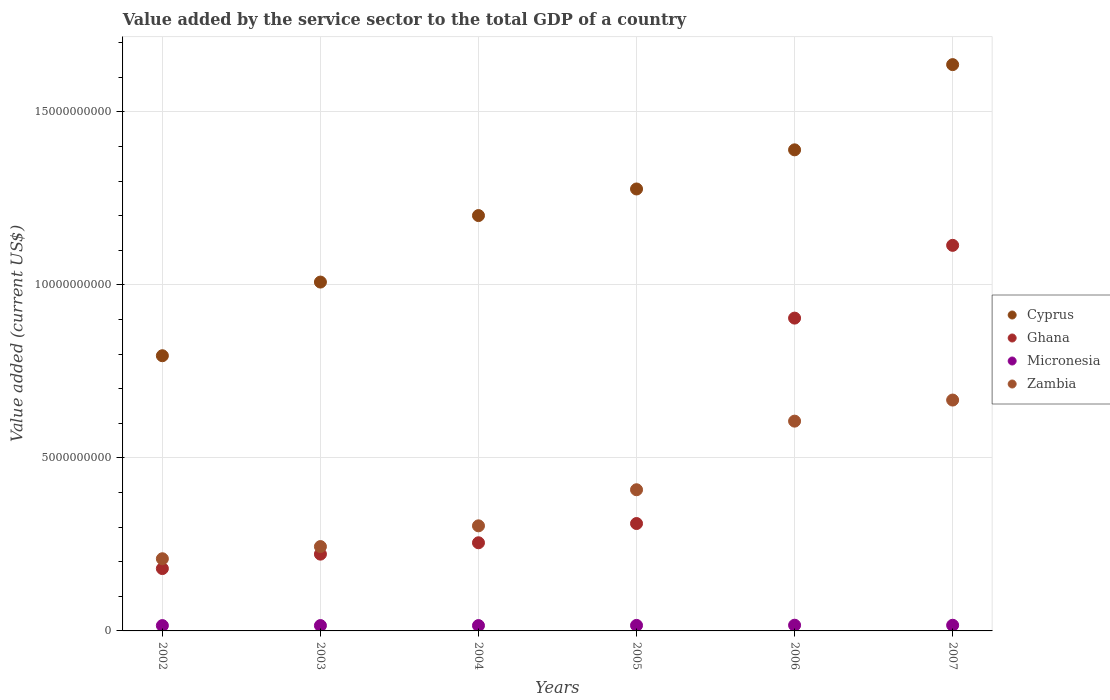Is the number of dotlines equal to the number of legend labels?
Your answer should be very brief. Yes. What is the value added by the service sector to the total GDP in Ghana in 2006?
Your response must be concise. 9.04e+09. Across all years, what is the maximum value added by the service sector to the total GDP in Ghana?
Provide a succinct answer. 1.11e+1. Across all years, what is the minimum value added by the service sector to the total GDP in Cyprus?
Keep it short and to the point. 7.95e+09. What is the total value added by the service sector to the total GDP in Ghana in the graph?
Offer a terse response. 2.98e+1. What is the difference between the value added by the service sector to the total GDP in Cyprus in 2005 and that in 2007?
Offer a terse response. -3.59e+09. What is the difference between the value added by the service sector to the total GDP in Ghana in 2004 and the value added by the service sector to the total GDP in Zambia in 2002?
Your response must be concise. 4.62e+08. What is the average value added by the service sector to the total GDP in Cyprus per year?
Ensure brevity in your answer.  1.22e+1. In the year 2005, what is the difference between the value added by the service sector to the total GDP in Zambia and value added by the service sector to the total GDP in Micronesia?
Provide a short and direct response. 3.92e+09. What is the ratio of the value added by the service sector to the total GDP in Ghana in 2002 to that in 2003?
Provide a short and direct response. 0.81. Is the value added by the service sector to the total GDP in Cyprus in 2002 less than that in 2003?
Ensure brevity in your answer.  Yes. Is the difference between the value added by the service sector to the total GDP in Zambia in 2004 and 2005 greater than the difference between the value added by the service sector to the total GDP in Micronesia in 2004 and 2005?
Offer a very short reply. No. What is the difference between the highest and the second highest value added by the service sector to the total GDP in Cyprus?
Your answer should be compact. 2.46e+09. What is the difference between the highest and the lowest value added by the service sector to the total GDP in Micronesia?
Your response must be concise. 1.13e+07. In how many years, is the value added by the service sector to the total GDP in Zambia greater than the average value added by the service sector to the total GDP in Zambia taken over all years?
Your answer should be compact. 3. Is the sum of the value added by the service sector to the total GDP in Zambia in 2004 and 2005 greater than the maximum value added by the service sector to the total GDP in Ghana across all years?
Offer a terse response. No. Is it the case that in every year, the sum of the value added by the service sector to the total GDP in Micronesia and value added by the service sector to the total GDP in Cyprus  is greater than the value added by the service sector to the total GDP in Zambia?
Make the answer very short. Yes. Does the value added by the service sector to the total GDP in Cyprus monotonically increase over the years?
Make the answer very short. Yes. Is the value added by the service sector to the total GDP in Ghana strictly greater than the value added by the service sector to the total GDP in Zambia over the years?
Offer a very short reply. No. Is the value added by the service sector to the total GDP in Zambia strictly less than the value added by the service sector to the total GDP in Micronesia over the years?
Offer a terse response. No. How many dotlines are there?
Offer a very short reply. 4. How many years are there in the graph?
Your answer should be very brief. 6. What is the difference between two consecutive major ticks on the Y-axis?
Offer a terse response. 5.00e+09. Where does the legend appear in the graph?
Offer a terse response. Center right. How are the legend labels stacked?
Provide a short and direct response. Vertical. What is the title of the graph?
Offer a terse response. Value added by the service sector to the total GDP of a country. What is the label or title of the X-axis?
Ensure brevity in your answer.  Years. What is the label or title of the Y-axis?
Give a very brief answer. Value added (current US$). What is the Value added (current US$) in Cyprus in 2002?
Provide a succinct answer. 7.95e+09. What is the Value added (current US$) of Ghana in 2002?
Provide a succinct answer. 1.80e+09. What is the Value added (current US$) in Micronesia in 2002?
Offer a very short reply. 1.54e+08. What is the Value added (current US$) of Zambia in 2002?
Your answer should be very brief. 2.09e+09. What is the Value added (current US$) of Cyprus in 2003?
Your answer should be very brief. 1.01e+1. What is the Value added (current US$) in Ghana in 2003?
Keep it short and to the point. 2.22e+09. What is the Value added (current US$) in Micronesia in 2003?
Ensure brevity in your answer.  1.55e+08. What is the Value added (current US$) of Zambia in 2003?
Ensure brevity in your answer.  2.44e+09. What is the Value added (current US$) of Cyprus in 2004?
Ensure brevity in your answer.  1.20e+1. What is the Value added (current US$) of Ghana in 2004?
Your response must be concise. 2.55e+09. What is the Value added (current US$) of Micronesia in 2004?
Make the answer very short. 1.54e+08. What is the Value added (current US$) of Zambia in 2004?
Ensure brevity in your answer.  3.04e+09. What is the Value added (current US$) in Cyprus in 2005?
Provide a short and direct response. 1.28e+1. What is the Value added (current US$) in Ghana in 2005?
Your response must be concise. 3.10e+09. What is the Value added (current US$) in Micronesia in 2005?
Ensure brevity in your answer.  1.60e+08. What is the Value added (current US$) of Zambia in 2005?
Ensure brevity in your answer.  4.08e+09. What is the Value added (current US$) in Cyprus in 2006?
Provide a short and direct response. 1.39e+1. What is the Value added (current US$) in Ghana in 2006?
Make the answer very short. 9.04e+09. What is the Value added (current US$) in Micronesia in 2006?
Offer a terse response. 1.65e+08. What is the Value added (current US$) in Zambia in 2006?
Provide a short and direct response. 6.06e+09. What is the Value added (current US$) in Cyprus in 2007?
Keep it short and to the point. 1.64e+1. What is the Value added (current US$) of Ghana in 2007?
Offer a very short reply. 1.11e+1. What is the Value added (current US$) of Micronesia in 2007?
Ensure brevity in your answer.  1.64e+08. What is the Value added (current US$) of Zambia in 2007?
Your answer should be compact. 6.67e+09. Across all years, what is the maximum Value added (current US$) of Cyprus?
Your answer should be compact. 1.64e+1. Across all years, what is the maximum Value added (current US$) in Ghana?
Your answer should be compact. 1.11e+1. Across all years, what is the maximum Value added (current US$) of Micronesia?
Provide a succinct answer. 1.65e+08. Across all years, what is the maximum Value added (current US$) in Zambia?
Offer a very short reply. 6.67e+09. Across all years, what is the minimum Value added (current US$) of Cyprus?
Provide a short and direct response. 7.95e+09. Across all years, what is the minimum Value added (current US$) of Ghana?
Offer a terse response. 1.80e+09. Across all years, what is the minimum Value added (current US$) in Micronesia?
Your answer should be very brief. 1.54e+08. Across all years, what is the minimum Value added (current US$) in Zambia?
Provide a short and direct response. 2.09e+09. What is the total Value added (current US$) of Cyprus in the graph?
Give a very brief answer. 7.31e+1. What is the total Value added (current US$) of Ghana in the graph?
Ensure brevity in your answer.  2.98e+1. What is the total Value added (current US$) in Micronesia in the graph?
Keep it short and to the point. 9.51e+08. What is the total Value added (current US$) of Zambia in the graph?
Provide a short and direct response. 2.44e+1. What is the difference between the Value added (current US$) in Cyprus in 2002 and that in 2003?
Offer a very short reply. -2.13e+09. What is the difference between the Value added (current US$) of Ghana in 2002 and that in 2003?
Your response must be concise. -4.17e+08. What is the difference between the Value added (current US$) in Micronesia in 2002 and that in 2003?
Your answer should be very brief. -6.49e+05. What is the difference between the Value added (current US$) in Zambia in 2002 and that in 2003?
Keep it short and to the point. -3.52e+08. What is the difference between the Value added (current US$) in Cyprus in 2002 and that in 2004?
Your answer should be compact. -4.05e+09. What is the difference between the Value added (current US$) of Ghana in 2002 and that in 2004?
Your answer should be very brief. -7.46e+08. What is the difference between the Value added (current US$) in Micronesia in 2002 and that in 2004?
Give a very brief answer. -5.24e+05. What is the difference between the Value added (current US$) of Zambia in 2002 and that in 2004?
Provide a succinct answer. -9.51e+08. What is the difference between the Value added (current US$) in Cyprus in 2002 and that in 2005?
Provide a succinct answer. -4.82e+09. What is the difference between the Value added (current US$) in Ghana in 2002 and that in 2005?
Make the answer very short. -1.30e+09. What is the difference between the Value added (current US$) of Micronesia in 2002 and that in 2005?
Your answer should be compact. -5.68e+06. What is the difference between the Value added (current US$) of Zambia in 2002 and that in 2005?
Make the answer very short. -1.99e+09. What is the difference between the Value added (current US$) of Cyprus in 2002 and that in 2006?
Offer a terse response. -5.95e+09. What is the difference between the Value added (current US$) of Ghana in 2002 and that in 2006?
Your answer should be compact. -7.24e+09. What is the difference between the Value added (current US$) of Micronesia in 2002 and that in 2006?
Make the answer very short. -1.13e+07. What is the difference between the Value added (current US$) of Zambia in 2002 and that in 2006?
Your answer should be compact. -3.98e+09. What is the difference between the Value added (current US$) of Cyprus in 2002 and that in 2007?
Offer a very short reply. -8.41e+09. What is the difference between the Value added (current US$) in Ghana in 2002 and that in 2007?
Your answer should be compact. -9.34e+09. What is the difference between the Value added (current US$) in Micronesia in 2002 and that in 2007?
Ensure brevity in your answer.  -9.78e+06. What is the difference between the Value added (current US$) in Zambia in 2002 and that in 2007?
Keep it short and to the point. -4.59e+09. What is the difference between the Value added (current US$) in Cyprus in 2003 and that in 2004?
Offer a very short reply. -1.92e+09. What is the difference between the Value added (current US$) in Ghana in 2003 and that in 2004?
Your answer should be very brief. -3.29e+08. What is the difference between the Value added (current US$) of Micronesia in 2003 and that in 2004?
Your answer should be very brief. 1.25e+05. What is the difference between the Value added (current US$) of Zambia in 2003 and that in 2004?
Your response must be concise. -5.99e+08. What is the difference between the Value added (current US$) in Cyprus in 2003 and that in 2005?
Keep it short and to the point. -2.69e+09. What is the difference between the Value added (current US$) of Ghana in 2003 and that in 2005?
Provide a succinct answer. -8.85e+08. What is the difference between the Value added (current US$) of Micronesia in 2003 and that in 2005?
Offer a very short reply. -5.04e+06. What is the difference between the Value added (current US$) in Zambia in 2003 and that in 2005?
Make the answer very short. -1.64e+09. What is the difference between the Value added (current US$) of Cyprus in 2003 and that in 2006?
Your response must be concise. -3.82e+09. What is the difference between the Value added (current US$) of Ghana in 2003 and that in 2006?
Provide a succinct answer. -6.82e+09. What is the difference between the Value added (current US$) of Micronesia in 2003 and that in 2006?
Your response must be concise. -1.06e+07. What is the difference between the Value added (current US$) in Zambia in 2003 and that in 2006?
Your response must be concise. -3.62e+09. What is the difference between the Value added (current US$) in Cyprus in 2003 and that in 2007?
Give a very brief answer. -6.28e+09. What is the difference between the Value added (current US$) in Ghana in 2003 and that in 2007?
Make the answer very short. -8.92e+09. What is the difference between the Value added (current US$) of Micronesia in 2003 and that in 2007?
Your answer should be compact. -9.14e+06. What is the difference between the Value added (current US$) of Zambia in 2003 and that in 2007?
Provide a short and direct response. -4.23e+09. What is the difference between the Value added (current US$) in Cyprus in 2004 and that in 2005?
Keep it short and to the point. -7.69e+08. What is the difference between the Value added (current US$) of Ghana in 2004 and that in 2005?
Make the answer very short. -5.56e+08. What is the difference between the Value added (current US$) in Micronesia in 2004 and that in 2005?
Provide a short and direct response. -5.16e+06. What is the difference between the Value added (current US$) in Zambia in 2004 and that in 2005?
Keep it short and to the point. -1.04e+09. What is the difference between the Value added (current US$) of Cyprus in 2004 and that in 2006?
Provide a short and direct response. -1.90e+09. What is the difference between the Value added (current US$) in Ghana in 2004 and that in 2006?
Give a very brief answer. -6.49e+09. What is the difference between the Value added (current US$) in Micronesia in 2004 and that in 2006?
Give a very brief answer. -1.08e+07. What is the difference between the Value added (current US$) in Zambia in 2004 and that in 2006?
Offer a very short reply. -3.02e+09. What is the difference between the Value added (current US$) of Cyprus in 2004 and that in 2007?
Your answer should be compact. -4.36e+09. What is the difference between the Value added (current US$) in Ghana in 2004 and that in 2007?
Offer a terse response. -8.59e+09. What is the difference between the Value added (current US$) of Micronesia in 2004 and that in 2007?
Your answer should be compact. -9.26e+06. What is the difference between the Value added (current US$) in Zambia in 2004 and that in 2007?
Keep it short and to the point. -3.63e+09. What is the difference between the Value added (current US$) of Cyprus in 2005 and that in 2006?
Ensure brevity in your answer.  -1.13e+09. What is the difference between the Value added (current US$) in Ghana in 2005 and that in 2006?
Provide a succinct answer. -5.94e+09. What is the difference between the Value added (current US$) in Micronesia in 2005 and that in 2006?
Provide a succinct answer. -5.60e+06. What is the difference between the Value added (current US$) in Zambia in 2005 and that in 2006?
Provide a short and direct response. -1.98e+09. What is the difference between the Value added (current US$) in Cyprus in 2005 and that in 2007?
Your answer should be very brief. -3.59e+09. What is the difference between the Value added (current US$) of Ghana in 2005 and that in 2007?
Ensure brevity in your answer.  -8.04e+09. What is the difference between the Value added (current US$) of Micronesia in 2005 and that in 2007?
Offer a terse response. -4.10e+06. What is the difference between the Value added (current US$) in Zambia in 2005 and that in 2007?
Offer a terse response. -2.59e+09. What is the difference between the Value added (current US$) in Cyprus in 2006 and that in 2007?
Your answer should be very brief. -2.46e+09. What is the difference between the Value added (current US$) of Ghana in 2006 and that in 2007?
Your response must be concise. -2.10e+09. What is the difference between the Value added (current US$) in Micronesia in 2006 and that in 2007?
Your answer should be very brief. 1.50e+06. What is the difference between the Value added (current US$) of Zambia in 2006 and that in 2007?
Offer a terse response. -6.09e+08. What is the difference between the Value added (current US$) in Cyprus in 2002 and the Value added (current US$) in Ghana in 2003?
Offer a terse response. 5.73e+09. What is the difference between the Value added (current US$) in Cyprus in 2002 and the Value added (current US$) in Micronesia in 2003?
Provide a short and direct response. 7.80e+09. What is the difference between the Value added (current US$) in Cyprus in 2002 and the Value added (current US$) in Zambia in 2003?
Your answer should be very brief. 5.51e+09. What is the difference between the Value added (current US$) in Ghana in 2002 and the Value added (current US$) in Micronesia in 2003?
Provide a succinct answer. 1.65e+09. What is the difference between the Value added (current US$) of Ghana in 2002 and the Value added (current US$) of Zambia in 2003?
Ensure brevity in your answer.  -6.36e+08. What is the difference between the Value added (current US$) of Micronesia in 2002 and the Value added (current US$) of Zambia in 2003?
Provide a short and direct response. -2.28e+09. What is the difference between the Value added (current US$) in Cyprus in 2002 and the Value added (current US$) in Ghana in 2004?
Provide a short and direct response. 5.40e+09. What is the difference between the Value added (current US$) in Cyprus in 2002 and the Value added (current US$) in Micronesia in 2004?
Provide a succinct answer. 7.80e+09. What is the difference between the Value added (current US$) in Cyprus in 2002 and the Value added (current US$) in Zambia in 2004?
Give a very brief answer. 4.91e+09. What is the difference between the Value added (current US$) of Ghana in 2002 and the Value added (current US$) of Micronesia in 2004?
Ensure brevity in your answer.  1.65e+09. What is the difference between the Value added (current US$) in Ghana in 2002 and the Value added (current US$) in Zambia in 2004?
Provide a short and direct response. -1.24e+09. What is the difference between the Value added (current US$) in Micronesia in 2002 and the Value added (current US$) in Zambia in 2004?
Your answer should be compact. -2.88e+09. What is the difference between the Value added (current US$) of Cyprus in 2002 and the Value added (current US$) of Ghana in 2005?
Provide a succinct answer. 4.85e+09. What is the difference between the Value added (current US$) of Cyprus in 2002 and the Value added (current US$) of Micronesia in 2005?
Your answer should be very brief. 7.79e+09. What is the difference between the Value added (current US$) in Cyprus in 2002 and the Value added (current US$) in Zambia in 2005?
Provide a short and direct response. 3.87e+09. What is the difference between the Value added (current US$) in Ghana in 2002 and the Value added (current US$) in Micronesia in 2005?
Offer a terse response. 1.64e+09. What is the difference between the Value added (current US$) in Ghana in 2002 and the Value added (current US$) in Zambia in 2005?
Give a very brief answer. -2.28e+09. What is the difference between the Value added (current US$) of Micronesia in 2002 and the Value added (current US$) of Zambia in 2005?
Offer a terse response. -3.93e+09. What is the difference between the Value added (current US$) of Cyprus in 2002 and the Value added (current US$) of Ghana in 2006?
Offer a very short reply. -1.09e+09. What is the difference between the Value added (current US$) in Cyprus in 2002 and the Value added (current US$) in Micronesia in 2006?
Offer a terse response. 7.79e+09. What is the difference between the Value added (current US$) in Cyprus in 2002 and the Value added (current US$) in Zambia in 2006?
Your answer should be compact. 1.89e+09. What is the difference between the Value added (current US$) of Ghana in 2002 and the Value added (current US$) of Micronesia in 2006?
Ensure brevity in your answer.  1.64e+09. What is the difference between the Value added (current US$) of Ghana in 2002 and the Value added (current US$) of Zambia in 2006?
Offer a very short reply. -4.26e+09. What is the difference between the Value added (current US$) in Micronesia in 2002 and the Value added (current US$) in Zambia in 2006?
Your response must be concise. -5.91e+09. What is the difference between the Value added (current US$) of Cyprus in 2002 and the Value added (current US$) of Ghana in 2007?
Provide a succinct answer. -3.19e+09. What is the difference between the Value added (current US$) in Cyprus in 2002 and the Value added (current US$) in Micronesia in 2007?
Your response must be concise. 7.79e+09. What is the difference between the Value added (current US$) in Cyprus in 2002 and the Value added (current US$) in Zambia in 2007?
Keep it short and to the point. 1.28e+09. What is the difference between the Value added (current US$) of Ghana in 2002 and the Value added (current US$) of Micronesia in 2007?
Your response must be concise. 1.64e+09. What is the difference between the Value added (current US$) of Ghana in 2002 and the Value added (current US$) of Zambia in 2007?
Ensure brevity in your answer.  -4.87e+09. What is the difference between the Value added (current US$) of Micronesia in 2002 and the Value added (current US$) of Zambia in 2007?
Provide a short and direct response. -6.52e+09. What is the difference between the Value added (current US$) of Cyprus in 2003 and the Value added (current US$) of Ghana in 2004?
Offer a terse response. 7.53e+09. What is the difference between the Value added (current US$) in Cyprus in 2003 and the Value added (current US$) in Micronesia in 2004?
Make the answer very short. 9.93e+09. What is the difference between the Value added (current US$) of Cyprus in 2003 and the Value added (current US$) of Zambia in 2004?
Make the answer very short. 7.04e+09. What is the difference between the Value added (current US$) of Ghana in 2003 and the Value added (current US$) of Micronesia in 2004?
Offer a terse response. 2.06e+09. What is the difference between the Value added (current US$) of Ghana in 2003 and the Value added (current US$) of Zambia in 2004?
Offer a terse response. -8.18e+08. What is the difference between the Value added (current US$) of Micronesia in 2003 and the Value added (current US$) of Zambia in 2004?
Make the answer very short. -2.88e+09. What is the difference between the Value added (current US$) in Cyprus in 2003 and the Value added (current US$) in Ghana in 2005?
Your response must be concise. 6.98e+09. What is the difference between the Value added (current US$) in Cyprus in 2003 and the Value added (current US$) in Micronesia in 2005?
Give a very brief answer. 9.92e+09. What is the difference between the Value added (current US$) of Cyprus in 2003 and the Value added (current US$) of Zambia in 2005?
Offer a very short reply. 6.00e+09. What is the difference between the Value added (current US$) of Ghana in 2003 and the Value added (current US$) of Micronesia in 2005?
Provide a short and direct response. 2.06e+09. What is the difference between the Value added (current US$) in Ghana in 2003 and the Value added (current US$) in Zambia in 2005?
Ensure brevity in your answer.  -1.86e+09. What is the difference between the Value added (current US$) in Micronesia in 2003 and the Value added (current US$) in Zambia in 2005?
Give a very brief answer. -3.92e+09. What is the difference between the Value added (current US$) in Cyprus in 2003 and the Value added (current US$) in Ghana in 2006?
Give a very brief answer. 1.04e+09. What is the difference between the Value added (current US$) of Cyprus in 2003 and the Value added (current US$) of Micronesia in 2006?
Offer a very short reply. 9.91e+09. What is the difference between the Value added (current US$) of Cyprus in 2003 and the Value added (current US$) of Zambia in 2006?
Provide a succinct answer. 4.02e+09. What is the difference between the Value added (current US$) of Ghana in 2003 and the Value added (current US$) of Micronesia in 2006?
Keep it short and to the point. 2.05e+09. What is the difference between the Value added (current US$) of Ghana in 2003 and the Value added (current US$) of Zambia in 2006?
Offer a terse response. -3.84e+09. What is the difference between the Value added (current US$) in Micronesia in 2003 and the Value added (current US$) in Zambia in 2006?
Your response must be concise. -5.91e+09. What is the difference between the Value added (current US$) of Cyprus in 2003 and the Value added (current US$) of Ghana in 2007?
Your answer should be very brief. -1.06e+09. What is the difference between the Value added (current US$) of Cyprus in 2003 and the Value added (current US$) of Micronesia in 2007?
Provide a short and direct response. 9.92e+09. What is the difference between the Value added (current US$) of Cyprus in 2003 and the Value added (current US$) of Zambia in 2007?
Your response must be concise. 3.41e+09. What is the difference between the Value added (current US$) of Ghana in 2003 and the Value added (current US$) of Micronesia in 2007?
Make the answer very short. 2.05e+09. What is the difference between the Value added (current US$) in Ghana in 2003 and the Value added (current US$) in Zambia in 2007?
Make the answer very short. -4.45e+09. What is the difference between the Value added (current US$) of Micronesia in 2003 and the Value added (current US$) of Zambia in 2007?
Your answer should be very brief. -6.52e+09. What is the difference between the Value added (current US$) of Cyprus in 2004 and the Value added (current US$) of Ghana in 2005?
Provide a succinct answer. 8.90e+09. What is the difference between the Value added (current US$) in Cyprus in 2004 and the Value added (current US$) in Micronesia in 2005?
Your response must be concise. 1.18e+1. What is the difference between the Value added (current US$) in Cyprus in 2004 and the Value added (current US$) in Zambia in 2005?
Provide a succinct answer. 7.92e+09. What is the difference between the Value added (current US$) in Ghana in 2004 and the Value added (current US$) in Micronesia in 2005?
Your answer should be very brief. 2.39e+09. What is the difference between the Value added (current US$) of Ghana in 2004 and the Value added (current US$) of Zambia in 2005?
Your answer should be very brief. -1.53e+09. What is the difference between the Value added (current US$) in Micronesia in 2004 and the Value added (current US$) in Zambia in 2005?
Provide a short and direct response. -3.92e+09. What is the difference between the Value added (current US$) of Cyprus in 2004 and the Value added (current US$) of Ghana in 2006?
Your answer should be very brief. 2.96e+09. What is the difference between the Value added (current US$) in Cyprus in 2004 and the Value added (current US$) in Micronesia in 2006?
Offer a very short reply. 1.18e+1. What is the difference between the Value added (current US$) in Cyprus in 2004 and the Value added (current US$) in Zambia in 2006?
Your response must be concise. 5.94e+09. What is the difference between the Value added (current US$) in Ghana in 2004 and the Value added (current US$) in Micronesia in 2006?
Your answer should be very brief. 2.38e+09. What is the difference between the Value added (current US$) of Ghana in 2004 and the Value added (current US$) of Zambia in 2006?
Provide a short and direct response. -3.51e+09. What is the difference between the Value added (current US$) in Micronesia in 2004 and the Value added (current US$) in Zambia in 2006?
Your answer should be compact. -5.91e+09. What is the difference between the Value added (current US$) of Cyprus in 2004 and the Value added (current US$) of Ghana in 2007?
Your answer should be compact. 8.60e+08. What is the difference between the Value added (current US$) of Cyprus in 2004 and the Value added (current US$) of Micronesia in 2007?
Offer a very short reply. 1.18e+1. What is the difference between the Value added (current US$) in Cyprus in 2004 and the Value added (current US$) in Zambia in 2007?
Offer a very short reply. 5.33e+09. What is the difference between the Value added (current US$) of Ghana in 2004 and the Value added (current US$) of Micronesia in 2007?
Your answer should be very brief. 2.38e+09. What is the difference between the Value added (current US$) of Ghana in 2004 and the Value added (current US$) of Zambia in 2007?
Ensure brevity in your answer.  -4.12e+09. What is the difference between the Value added (current US$) of Micronesia in 2004 and the Value added (current US$) of Zambia in 2007?
Your answer should be very brief. -6.52e+09. What is the difference between the Value added (current US$) of Cyprus in 2005 and the Value added (current US$) of Ghana in 2006?
Offer a terse response. 3.73e+09. What is the difference between the Value added (current US$) in Cyprus in 2005 and the Value added (current US$) in Micronesia in 2006?
Provide a short and direct response. 1.26e+1. What is the difference between the Value added (current US$) in Cyprus in 2005 and the Value added (current US$) in Zambia in 2006?
Give a very brief answer. 6.71e+09. What is the difference between the Value added (current US$) of Ghana in 2005 and the Value added (current US$) of Micronesia in 2006?
Provide a short and direct response. 2.94e+09. What is the difference between the Value added (current US$) in Ghana in 2005 and the Value added (current US$) in Zambia in 2006?
Provide a short and direct response. -2.96e+09. What is the difference between the Value added (current US$) in Micronesia in 2005 and the Value added (current US$) in Zambia in 2006?
Your answer should be compact. -5.90e+09. What is the difference between the Value added (current US$) in Cyprus in 2005 and the Value added (current US$) in Ghana in 2007?
Provide a short and direct response. 1.63e+09. What is the difference between the Value added (current US$) of Cyprus in 2005 and the Value added (current US$) of Micronesia in 2007?
Keep it short and to the point. 1.26e+1. What is the difference between the Value added (current US$) of Cyprus in 2005 and the Value added (current US$) of Zambia in 2007?
Make the answer very short. 6.10e+09. What is the difference between the Value added (current US$) of Ghana in 2005 and the Value added (current US$) of Micronesia in 2007?
Offer a very short reply. 2.94e+09. What is the difference between the Value added (current US$) of Ghana in 2005 and the Value added (current US$) of Zambia in 2007?
Provide a short and direct response. -3.57e+09. What is the difference between the Value added (current US$) of Micronesia in 2005 and the Value added (current US$) of Zambia in 2007?
Make the answer very short. -6.51e+09. What is the difference between the Value added (current US$) in Cyprus in 2006 and the Value added (current US$) in Ghana in 2007?
Provide a short and direct response. 2.76e+09. What is the difference between the Value added (current US$) in Cyprus in 2006 and the Value added (current US$) in Micronesia in 2007?
Offer a very short reply. 1.37e+1. What is the difference between the Value added (current US$) of Cyprus in 2006 and the Value added (current US$) of Zambia in 2007?
Give a very brief answer. 7.23e+09. What is the difference between the Value added (current US$) in Ghana in 2006 and the Value added (current US$) in Micronesia in 2007?
Give a very brief answer. 8.87e+09. What is the difference between the Value added (current US$) in Ghana in 2006 and the Value added (current US$) in Zambia in 2007?
Make the answer very short. 2.37e+09. What is the difference between the Value added (current US$) of Micronesia in 2006 and the Value added (current US$) of Zambia in 2007?
Keep it short and to the point. -6.51e+09. What is the average Value added (current US$) of Cyprus per year?
Make the answer very short. 1.22e+1. What is the average Value added (current US$) of Ghana per year?
Give a very brief answer. 4.97e+09. What is the average Value added (current US$) in Micronesia per year?
Your response must be concise. 1.59e+08. What is the average Value added (current US$) of Zambia per year?
Give a very brief answer. 4.06e+09. In the year 2002, what is the difference between the Value added (current US$) in Cyprus and Value added (current US$) in Ghana?
Give a very brief answer. 6.15e+09. In the year 2002, what is the difference between the Value added (current US$) of Cyprus and Value added (current US$) of Micronesia?
Make the answer very short. 7.80e+09. In the year 2002, what is the difference between the Value added (current US$) of Cyprus and Value added (current US$) of Zambia?
Your response must be concise. 5.87e+09. In the year 2002, what is the difference between the Value added (current US$) of Ghana and Value added (current US$) of Micronesia?
Ensure brevity in your answer.  1.65e+09. In the year 2002, what is the difference between the Value added (current US$) of Ghana and Value added (current US$) of Zambia?
Keep it short and to the point. -2.84e+08. In the year 2002, what is the difference between the Value added (current US$) in Micronesia and Value added (current US$) in Zambia?
Ensure brevity in your answer.  -1.93e+09. In the year 2003, what is the difference between the Value added (current US$) in Cyprus and Value added (current US$) in Ghana?
Make the answer very short. 7.86e+09. In the year 2003, what is the difference between the Value added (current US$) of Cyprus and Value added (current US$) of Micronesia?
Offer a terse response. 9.93e+09. In the year 2003, what is the difference between the Value added (current US$) of Cyprus and Value added (current US$) of Zambia?
Offer a terse response. 7.64e+09. In the year 2003, what is the difference between the Value added (current US$) of Ghana and Value added (current US$) of Micronesia?
Provide a short and direct response. 2.06e+09. In the year 2003, what is the difference between the Value added (current US$) in Ghana and Value added (current US$) in Zambia?
Your answer should be very brief. -2.19e+08. In the year 2003, what is the difference between the Value added (current US$) in Micronesia and Value added (current US$) in Zambia?
Your answer should be compact. -2.28e+09. In the year 2004, what is the difference between the Value added (current US$) in Cyprus and Value added (current US$) in Ghana?
Offer a terse response. 9.45e+09. In the year 2004, what is the difference between the Value added (current US$) in Cyprus and Value added (current US$) in Micronesia?
Provide a short and direct response. 1.18e+1. In the year 2004, what is the difference between the Value added (current US$) in Cyprus and Value added (current US$) in Zambia?
Ensure brevity in your answer.  8.96e+09. In the year 2004, what is the difference between the Value added (current US$) of Ghana and Value added (current US$) of Micronesia?
Ensure brevity in your answer.  2.39e+09. In the year 2004, what is the difference between the Value added (current US$) of Ghana and Value added (current US$) of Zambia?
Offer a terse response. -4.89e+08. In the year 2004, what is the difference between the Value added (current US$) in Micronesia and Value added (current US$) in Zambia?
Make the answer very short. -2.88e+09. In the year 2005, what is the difference between the Value added (current US$) of Cyprus and Value added (current US$) of Ghana?
Make the answer very short. 9.67e+09. In the year 2005, what is the difference between the Value added (current US$) of Cyprus and Value added (current US$) of Micronesia?
Provide a succinct answer. 1.26e+1. In the year 2005, what is the difference between the Value added (current US$) in Cyprus and Value added (current US$) in Zambia?
Your answer should be very brief. 8.69e+09. In the year 2005, what is the difference between the Value added (current US$) in Ghana and Value added (current US$) in Micronesia?
Offer a terse response. 2.94e+09. In the year 2005, what is the difference between the Value added (current US$) of Ghana and Value added (current US$) of Zambia?
Offer a terse response. -9.76e+08. In the year 2005, what is the difference between the Value added (current US$) of Micronesia and Value added (current US$) of Zambia?
Keep it short and to the point. -3.92e+09. In the year 2006, what is the difference between the Value added (current US$) in Cyprus and Value added (current US$) in Ghana?
Your answer should be very brief. 4.86e+09. In the year 2006, what is the difference between the Value added (current US$) of Cyprus and Value added (current US$) of Micronesia?
Offer a very short reply. 1.37e+1. In the year 2006, what is the difference between the Value added (current US$) of Cyprus and Value added (current US$) of Zambia?
Your answer should be very brief. 7.84e+09. In the year 2006, what is the difference between the Value added (current US$) of Ghana and Value added (current US$) of Micronesia?
Your answer should be very brief. 8.87e+09. In the year 2006, what is the difference between the Value added (current US$) in Ghana and Value added (current US$) in Zambia?
Offer a very short reply. 2.98e+09. In the year 2006, what is the difference between the Value added (current US$) of Micronesia and Value added (current US$) of Zambia?
Your answer should be compact. -5.90e+09. In the year 2007, what is the difference between the Value added (current US$) in Cyprus and Value added (current US$) in Ghana?
Provide a short and direct response. 5.22e+09. In the year 2007, what is the difference between the Value added (current US$) of Cyprus and Value added (current US$) of Micronesia?
Ensure brevity in your answer.  1.62e+1. In the year 2007, what is the difference between the Value added (current US$) of Cyprus and Value added (current US$) of Zambia?
Give a very brief answer. 9.69e+09. In the year 2007, what is the difference between the Value added (current US$) of Ghana and Value added (current US$) of Micronesia?
Offer a very short reply. 1.10e+1. In the year 2007, what is the difference between the Value added (current US$) of Ghana and Value added (current US$) of Zambia?
Your answer should be very brief. 4.47e+09. In the year 2007, what is the difference between the Value added (current US$) of Micronesia and Value added (current US$) of Zambia?
Offer a very short reply. -6.51e+09. What is the ratio of the Value added (current US$) in Cyprus in 2002 to that in 2003?
Offer a very short reply. 0.79. What is the ratio of the Value added (current US$) of Ghana in 2002 to that in 2003?
Ensure brevity in your answer.  0.81. What is the ratio of the Value added (current US$) of Zambia in 2002 to that in 2003?
Provide a succinct answer. 0.86. What is the ratio of the Value added (current US$) of Cyprus in 2002 to that in 2004?
Provide a succinct answer. 0.66. What is the ratio of the Value added (current US$) in Ghana in 2002 to that in 2004?
Provide a succinct answer. 0.71. What is the ratio of the Value added (current US$) of Zambia in 2002 to that in 2004?
Offer a very short reply. 0.69. What is the ratio of the Value added (current US$) in Cyprus in 2002 to that in 2005?
Ensure brevity in your answer.  0.62. What is the ratio of the Value added (current US$) of Ghana in 2002 to that in 2005?
Keep it short and to the point. 0.58. What is the ratio of the Value added (current US$) of Micronesia in 2002 to that in 2005?
Offer a very short reply. 0.96. What is the ratio of the Value added (current US$) of Zambia in 2002 to that in 2005?
Give a very brief answer. 0.51. What is the ratio of the Value added (current US$) of Cyprus in 2002 to that in 2006?
Your response must be concise. 0.57. What is the ratio of the Value added (current US$) in Ghana in 2002 to that in 2006?
Ensure brevity in your answer.  0.2. What is the ratio of the Value added (current US$) of Micronesia in 2002 to that in 2006?
Your response must be concise. 0.93. What is the ratio of the Value added (current US$) in Zambia in 2002 to that in 2006?
Provide a succinct answer. 0.34. What is the ratio of the Value added (current US$) in Cyprus in 2002 to that in 2007?
Make the answer very short. 0.49. What is the ratio of the Value added (current US$) of Ghana in 2002 to that in 2007?
Offer a terse response. 0.16. What is the ratio of the Value added (current US$) in Micronesia in 2002 to that in 2007?
Give a very brief answer. 0.94. What is the ratio of the Value added (current US$) of Zambia in 2002 to that in 2007?
Your answer should be compact. 0.31. What is the ratio of the Value added (current US$) of Cyprus in 2003 to that in 2004?
Make the answer very short. 0.84. What is the ratio of the Value added (current US$) of Ghana in 2003 to that in 2004?
Give a very brief answer. 0.87. What is the ratio of the Value added (current US$) in Micronesia in 2003 to that in 2004?
Give a very brief answer. 1. What is the ratio of the Value added (current US$) in Zambia in 2003 to that in 2004?
Your answer should be compact. 0.8. What is the ratio of the Value added (current US$) in Cyprus in 2003 to that in 2005?
Make the answer very short. 0.79. What is the ratio of the Value added (current US$) in Ghana in 2003 to that in 2005?
Offer a terse response. 0.71. What is the ratio of the Value added (current US$) in Micronesia in 2003 to that in 2005?
Your response must be concise. 0.97. What is the ratio of the Value added (current US$) in Zambia in 2003 to that in 2005?
Provide a succinct answer. 0.6. What is the ratio of the Value added (current US$) in Cyprus in 2003 to that in 2006?
Provide a short and direct response. 0.73. What is the ratio of the Value added (current US$) of Ghana in 2003 to that in 2006?
Make the answer very short. 0.25. What is the ratio of the Value added (current US$) in Micronesia in 2003 to that in 2006?
Your answer should be compact. 0.94. What is the ratio of the Value added (current US$) of Zambia in 2003 to that in 2006?
Keep it short and to the point. 0.4. What is the ratio of the Value added (current US$) of Cyprus in 2003 to that in 2007?
Your answer should be very brief. 0.62. What is the ratio of the Value added (current US$) in Ghana in 2003 to that in 2007?
Offer a terse response. 0.2. What is the ratio of the Value added (current US$) of Micronesia in 2003 to that in 2007?
Give a very brief answer. 0.94. What is the ratio of the Value added (current US$) in Zambia in 2003 to that in 2007?
Make the answer very short. 0.37. What is the ratio of the Value added (current US$) in Cyprus in 2004 to that in 2005?
Your response must be concise. 0.94. What is the ratio of the Value added (current US$) of Ghana in 2004 to that in 2005?
Your response must be concise. 0.82. What is the ratio of the Value added (current US$) of Zambia in 2004 to that in 2005?
Ensure brevity in your answer.  0.74. What is the ratio of the Value added (current US$) in Cyprus in 2004 to that in 2006?
Make the answer very short. 0.86. What is the ratio of the Value added (current US$) in Ghana in 2004 to that in 2006?
Ensure brevity in your answer.  0.28. What is the ratio of the Value added (current US$) of Micronesia in 2004 to that in 2006?
Keep it short and to the point. 0.93. What is the ratio of the Value added (current US$) of Zambia in 2004 to that in 2006?
Your answer should be compact. 0.5. What is the ratio of the Value added (current US$) in Cyprus in 2004 to that in 2007?
Provide a succinct answer. 0.73. What is the ratio of the Value added (current US$) of Ghana in 2004 to that in 2007?
Ensure brevity in your answer.  0.23. What is the ratio of the Value added (current US$) in Micronesia in 2004 to that in 2007?
Your answer should be compact. 0.94. What is the ratio of the Value added (current US$) of Zambia in 2004 to that in 2007?
Make the answer very short. 0.46. What is the ratio of the Value added (current US$) of Cyprus in 2005 to that in 2006?
Offer a terse response. 0.92. What is the ratio of the Value added (current US$) of Ghana in 2005 to that in 2006?
Provide a succinct answer. 0.34. What is the ratio of the Value added (current US$) of Micronesia in 2005 to that in 2006?
Offer a terse response. 0.97. What is the ratio of the Value added (current US$) in Zambia in 2005 to that in 2006?
Provide a short and direct response. 0.67. What is the ratio of the Value added (current US$) in Cyprus in 2005 to that in 2007?
Provide a short and direct response. 0.78. What is the ratio of the Value added (current US$) in Ghana in 2005 to that in 2007?
Keep it short and to the point. 0.28. What is the ratio of the Value added (current US$) of Micronesia in 2005 to that in 2007?
Make the answer very short. 0.97. What is the ratio of the Value added (current US$) of Zambia in 2005 to that in 2007?
Offer a terse response. 0.61. What is the ratio of the Value added (current US$) of Cyprus in 2006 to that in 2007?
Your answer should be very brief. 0.85. What is the ratio of the Value added (current US$) in Ghana in 2006 to that in 2007?
Your answer should be compact. 0.81. What is the ratio of the Value added (current US$) in Micronesia in 2006 to that in 2007?
Ensure brevity in your answer.  1.01. What is the ratio of the Value added (current US$) of Zambia in 2006 to that in 2007?
Your answer should be compact. 0.91. What is the difference between the highest and the second highest Value added (current US$) in Cyprus?
Give a very brief answer. 2.46e+09. What is the difference between the highest and the second highest Value added (current US$) of Ghana?
Make the answer very short. 2.10e+09. What is the difference between the highest and the second highest Value added (current US$) in Micronesia?
Offer a very short reply. 1.50e+06. What is the difference between the highest and the second highest Value added (current US$) in Zambia?
Provide a short and direct response. 6.09e+08. What is the difference between the highest and the lowest Value added (current US$) in Cyprus?
Your response must be concise. 8.41e+09. What is the difference between the highest and the lowest Value added (current US$) of Ghana?
Offer a terse response. 9.34e+09. What is the difference between the highest and the lowest Value added (current US$) of Micronesia?
Your answer should be compact. 1.13e+07. What is the difference between the highest and the lowest Value added (current US$) of Zambia?
Provide a succinct answer. 4.59e+09. 